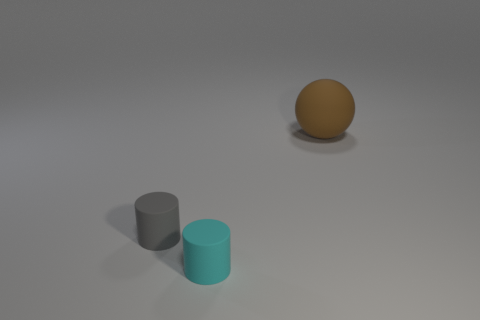What number of objects are small cyan things or matte things in front of the gray cylinder? In the image, there are two objects in front of the gray cylinder when facing it head-on: a small cyan cylinder and a brown sphere. The brown sphere appears to have a matte finish. Therefore, there are two objects that fit the description of being either small cyan things or matte things in front of the gray cylinder. 